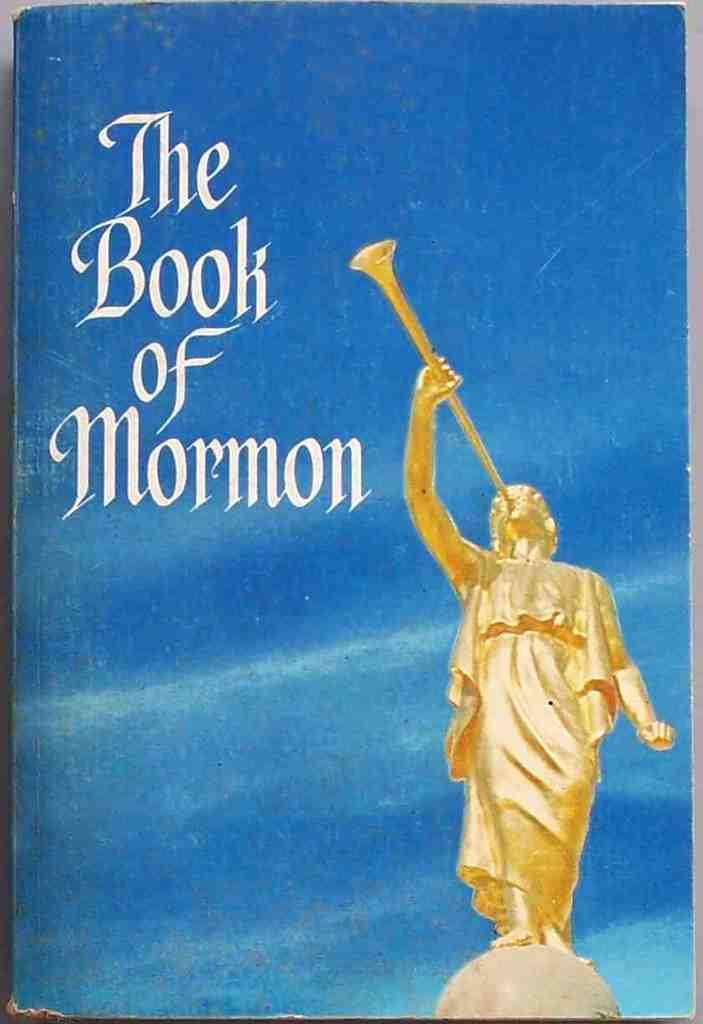Provide a one-sentence caption for the provided image. A book entitled "The Book of Mormon" has a blue cover. 